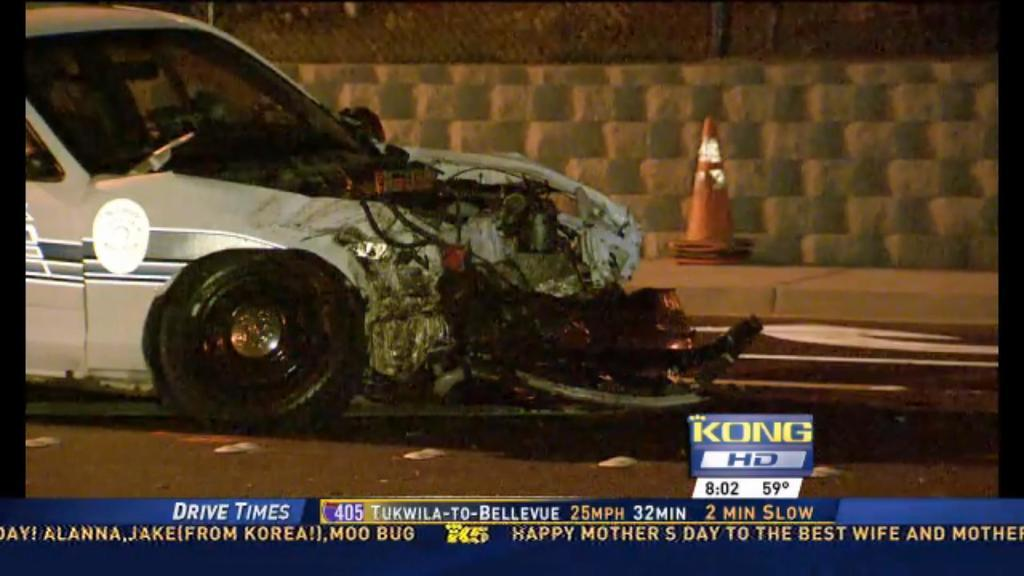What type of information is displayed in the image? The image contains news headlines. What can be seen on the road in the image? There is a scrapped car on the road in the image. What is behind the car in the image? There is a wall behind the car in the image. Where are the news headlines located in the image? The headlines are displayed at the bottom of the image. How many dolls are sitting on the kettle in the image? There are no dolls or kettles present in the image. What is the name of the daughter mentioned in the image? There is no mention of a daughter in the image. 